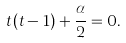Convert formula to latex. <formula><loc_0><loc_0><loc_500><loc_500>t ( t - 1 ) + \frac { \alpha } 2 = 0 .</formula> 